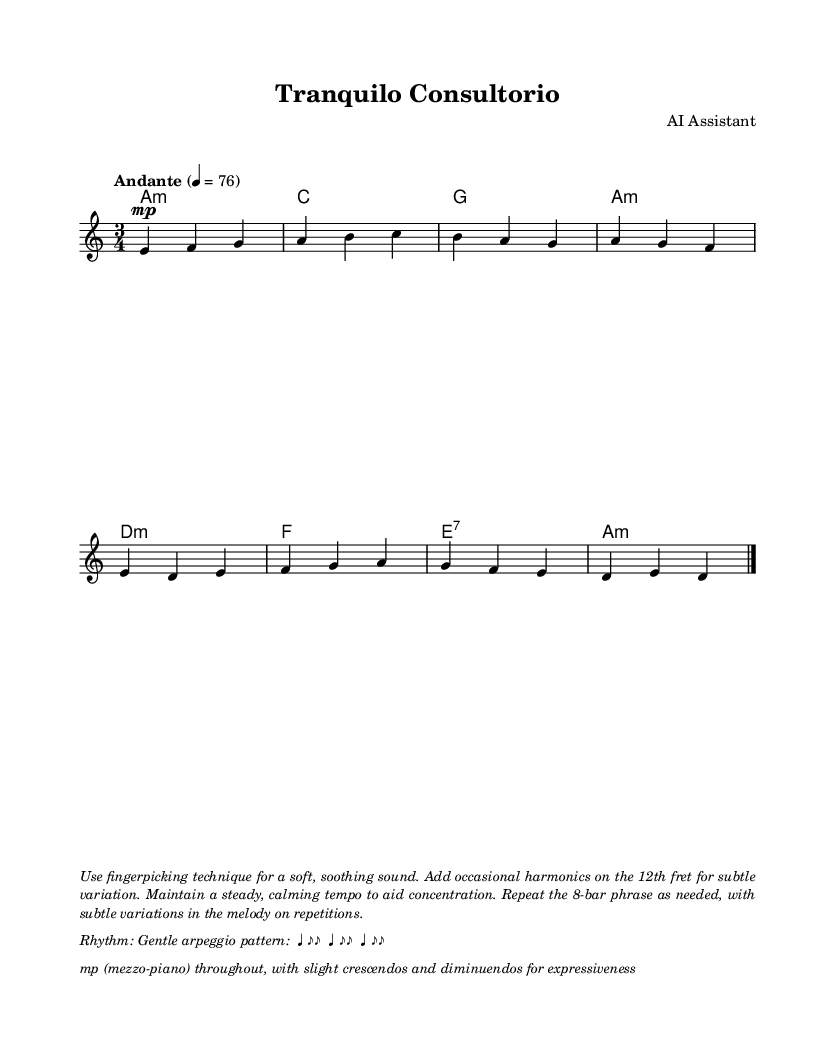What is the key signature of this music? The key signature is A minor, which has no sharps or flats. This can be determined from the key indicated at the beginning of the score before the notes start.
Answer: A minor What is the time signature of the piece? The time signature is 3/4, indicated at the beginning of the score, which signifies three beats per measure with a quarter note getting one beat.
Answer: 3/4 What is the tempo marking for this piece? The tempo marking is Andante, which is specifically noted in the score and denotes a moderate walking pace. The metronome marking is 76 beats per minute.
Answer: Andante How many measures are repeated in the piece? The score repeats the 8-bar phrase, indicated by the repeated volta notations. This is confirmed by the presence of the repeat signs at the beginning of the section.
Answer: 8 What dynamic level is indicated for the majority of the piece? The dynamic level is mezzo-piano, as indicated in the dynamics marking found at the beginning of the guitar part. This indicates a moderately soft intensity throughout the piece.
Answer: mezzo-piano What fingerstyle technique is recommended for this piece? The technique recommended is fingerpicking, highlighted in the markup instructions, which allows for a soft and soothing sound suitable for the intended purpose of aiding concentration.
Answer: Fingerpicking What type of harmonics are suggested for variation? The suggested harmonics are on the 12th fret, mentioned in the instructions provided in the markup. This adds subtle variation to the performance while maintaining the calming nature of the piece.
Answer: 12th fret 